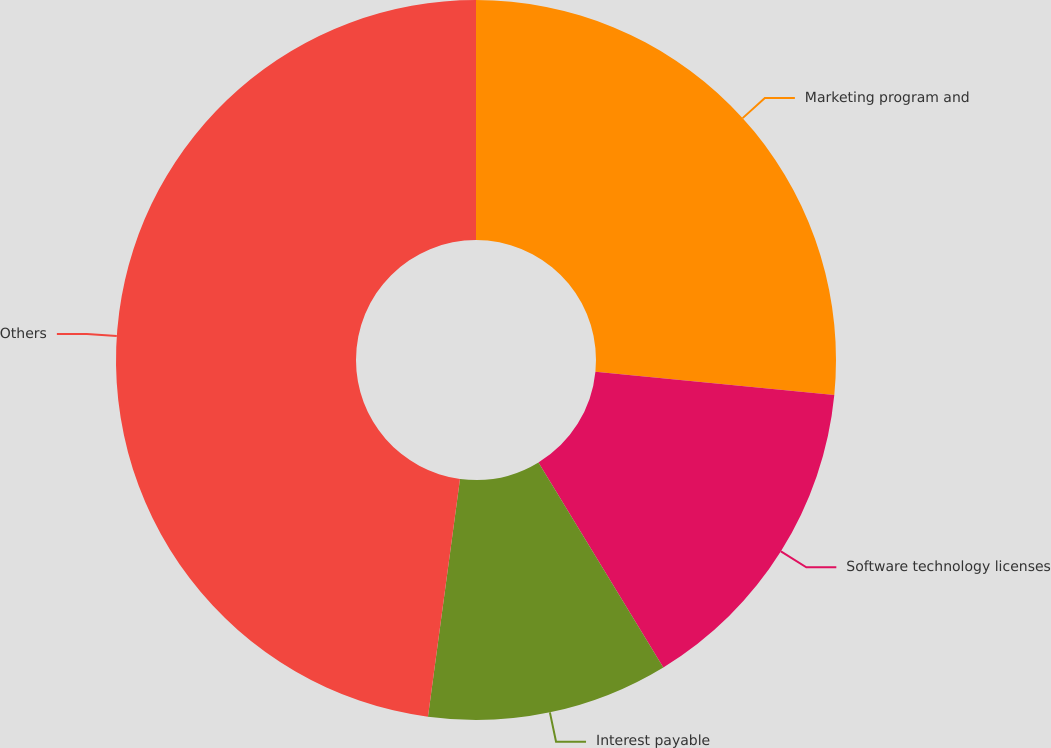<chart> <loc_0><loc_0><loc_500><loc_500><pie_chart><fcel>Marketing program and<fcel>Software technology licenses<fcel>Interest payable<fcel>Others<nl><fcel>26.55%<fcel>14.74%<fcel>10.84%<fcel>47.87%<nl></chart> 